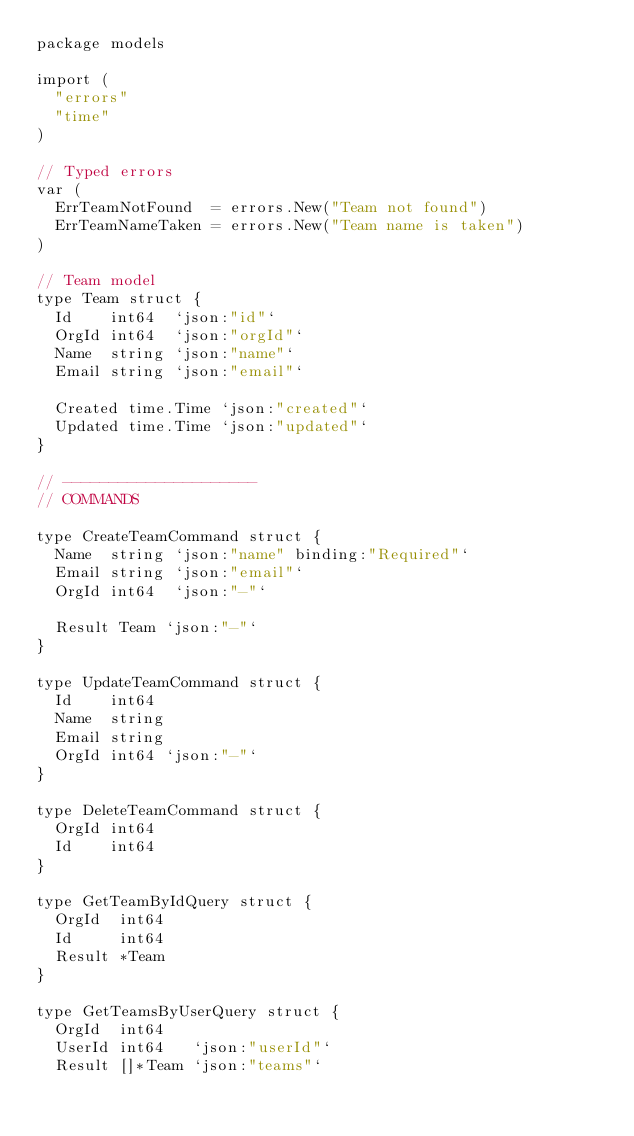Convert code to text. <code><loc_0><loc_0><loc_500><loc_500><_Go_>package models

import (
	"errors"
	"time"
)

// Typed errors
var (
	ErrTeamNotFound  = errors.New("Team not found")
	ErrTeamNameTaken = errors.New("Team name is taken")
)

// Team model
type Team struct {
	Id    int64  `json:"id"`
	OrgId int64  `json:"orgId"`
	Name  string `json:"name"`
	Email string `json:"email"`

	Created time.Time `json:"created"`
	Updated time.Time `json:"updated"`
}

// ---------------------
// COMMANDS

type CreateTeamCommand struct {
	Name  string `json:"name" binding:"Required"`
	Email string `json:"email"`
	OrgId int64  `json:"-"`

	Result Team `json:"-"`
}

type UpdateTeamCommand struct {
	Id    int64
	Name  string
	Email string
	OrgId int64 `json:"-"`
}

type DeleteTeamCommand struct {
	OrgId int64
	Id    int64
}

type GetTeamByIdQuery struct {
	OrgId  int64
	Id     int64
	Result *Team
}

type GetTeamsByUserQuery struct {
	OrgId  int64
	UserId int64   `json:"userId"`
	Result []*Team `json:"teams"`</code> 